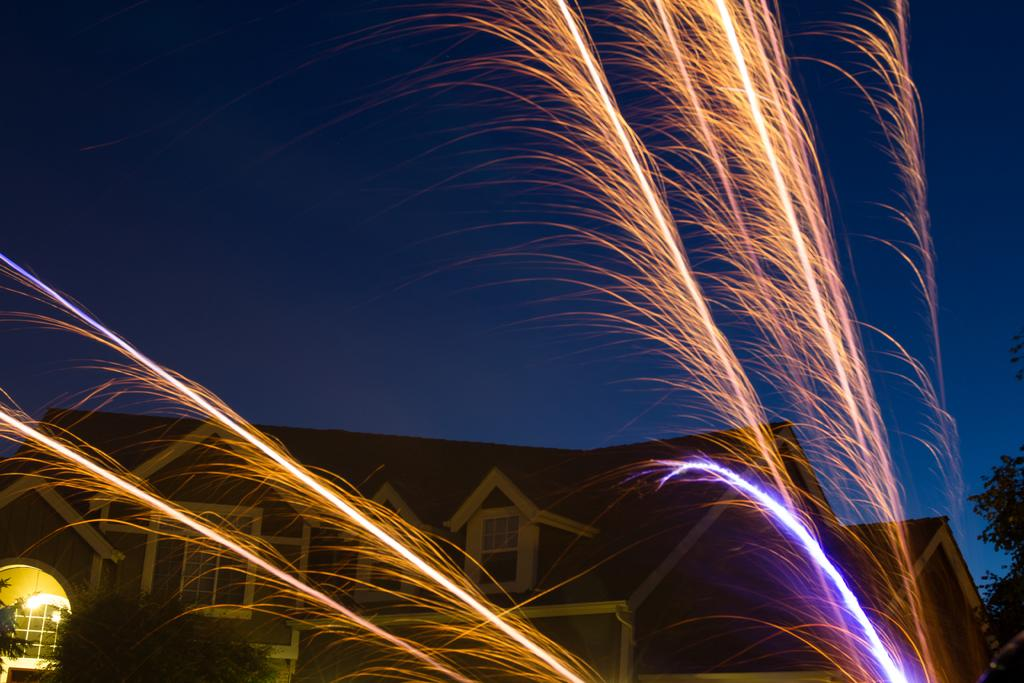What is the main structure in the image? There is a building in the center of the image. What is happening in the sky in the image? Fireworks are present in the image. What type of natural elements can be seen in the image? There are trees in the image. What is visible in the background of the image? The sky is visible in the background of the image. What type of blade is being used to carve the turkey in the image? There is no turkey or blade present in the image. How is the turkey being measured in the image? There is no turkey or measuring device present in the image. 